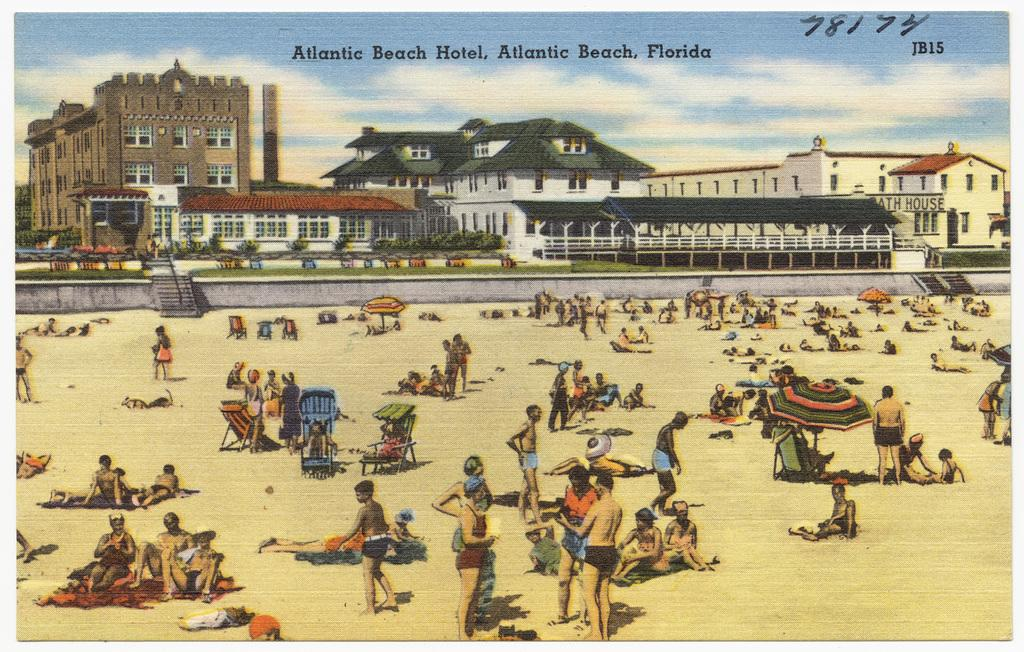How many people are at the bottom of the image? There are many people at the bottom of the image. What objects are present at the bottom of the image besides people? There are umbrellas, chairs, and clothes at the bottom of the image. What can be seen in the middle of the image? There are houses, a staircase, grass, plants, text, and the sky visible in the middle of the image. What is the condition of the sky in the middle of the image? The sky is visible in the middle of the image, and there are clouds in the sky. How many minutes does it take for the cows to graze in the image? There are no cows present in the image, so it is not possible to determine how long it takes for them to graze. 